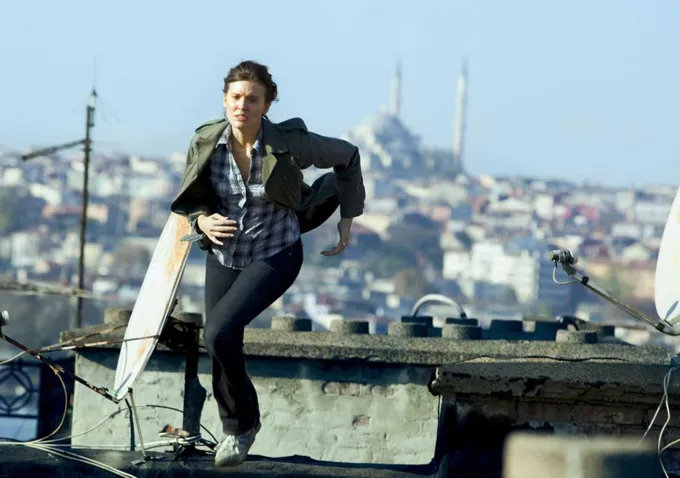What could be the reason for the person's urgent run? The person's run appears to be fueled by a sense of urgency, possibly due to an emergency, a pursuit, or the need to reach a destination quickly. The exact reason is not clear from the image alone, but the intensity on their face and the focused stride suggest a high-stakes scenario. What time of day does this scene appear to be set? The image suggests the scene is set during the day, given the clear blue sky and the strong sunlight casting shadows on the rooftop and the person. The visibility is high, allowing details of the cityscape to be seen clearly in the distance. 